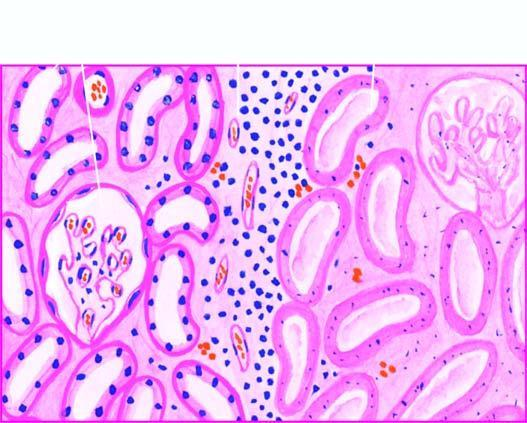what shows cells with intensely eosinophilic cytoplasm of tubular cells?
Answer the question using a single word or phrase. The affected area on right 